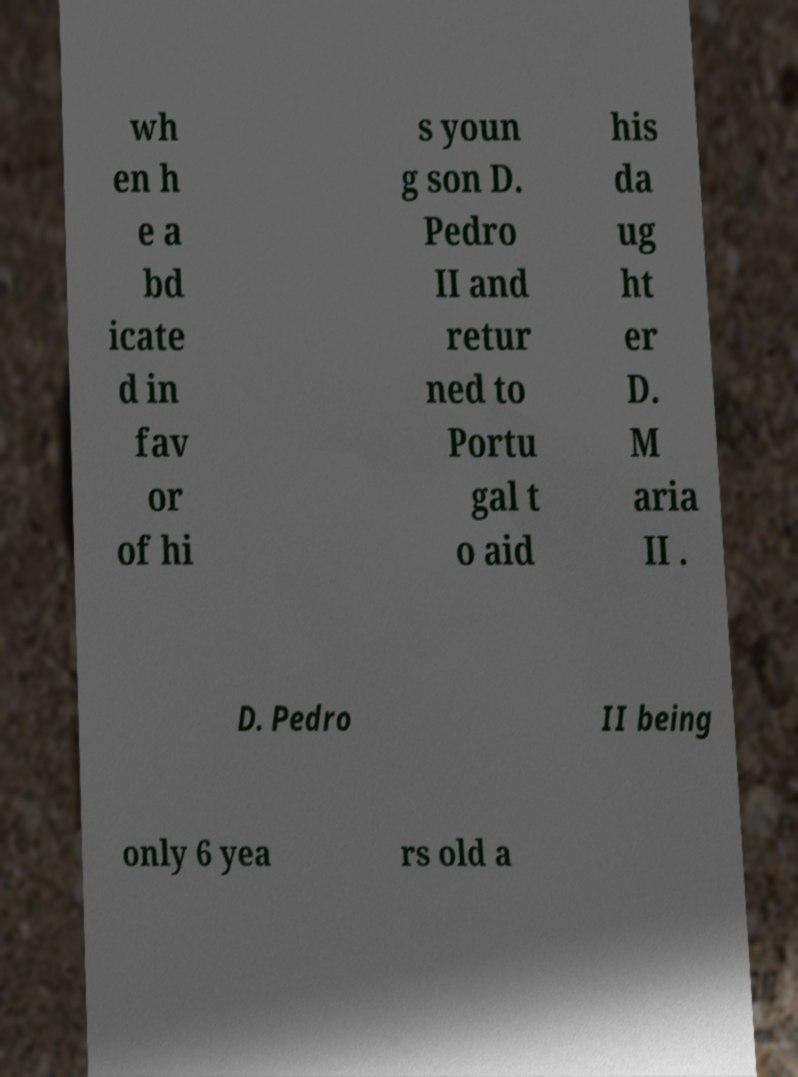Could you extract and type out the text from this image? wh en h e a bd icate d in fav or of hi s youn g son D. Pedro II and retur ned to Portu gal t o aid his da ug ht er D. M aria II . D. Pedro II being only 6 yea rs old a 